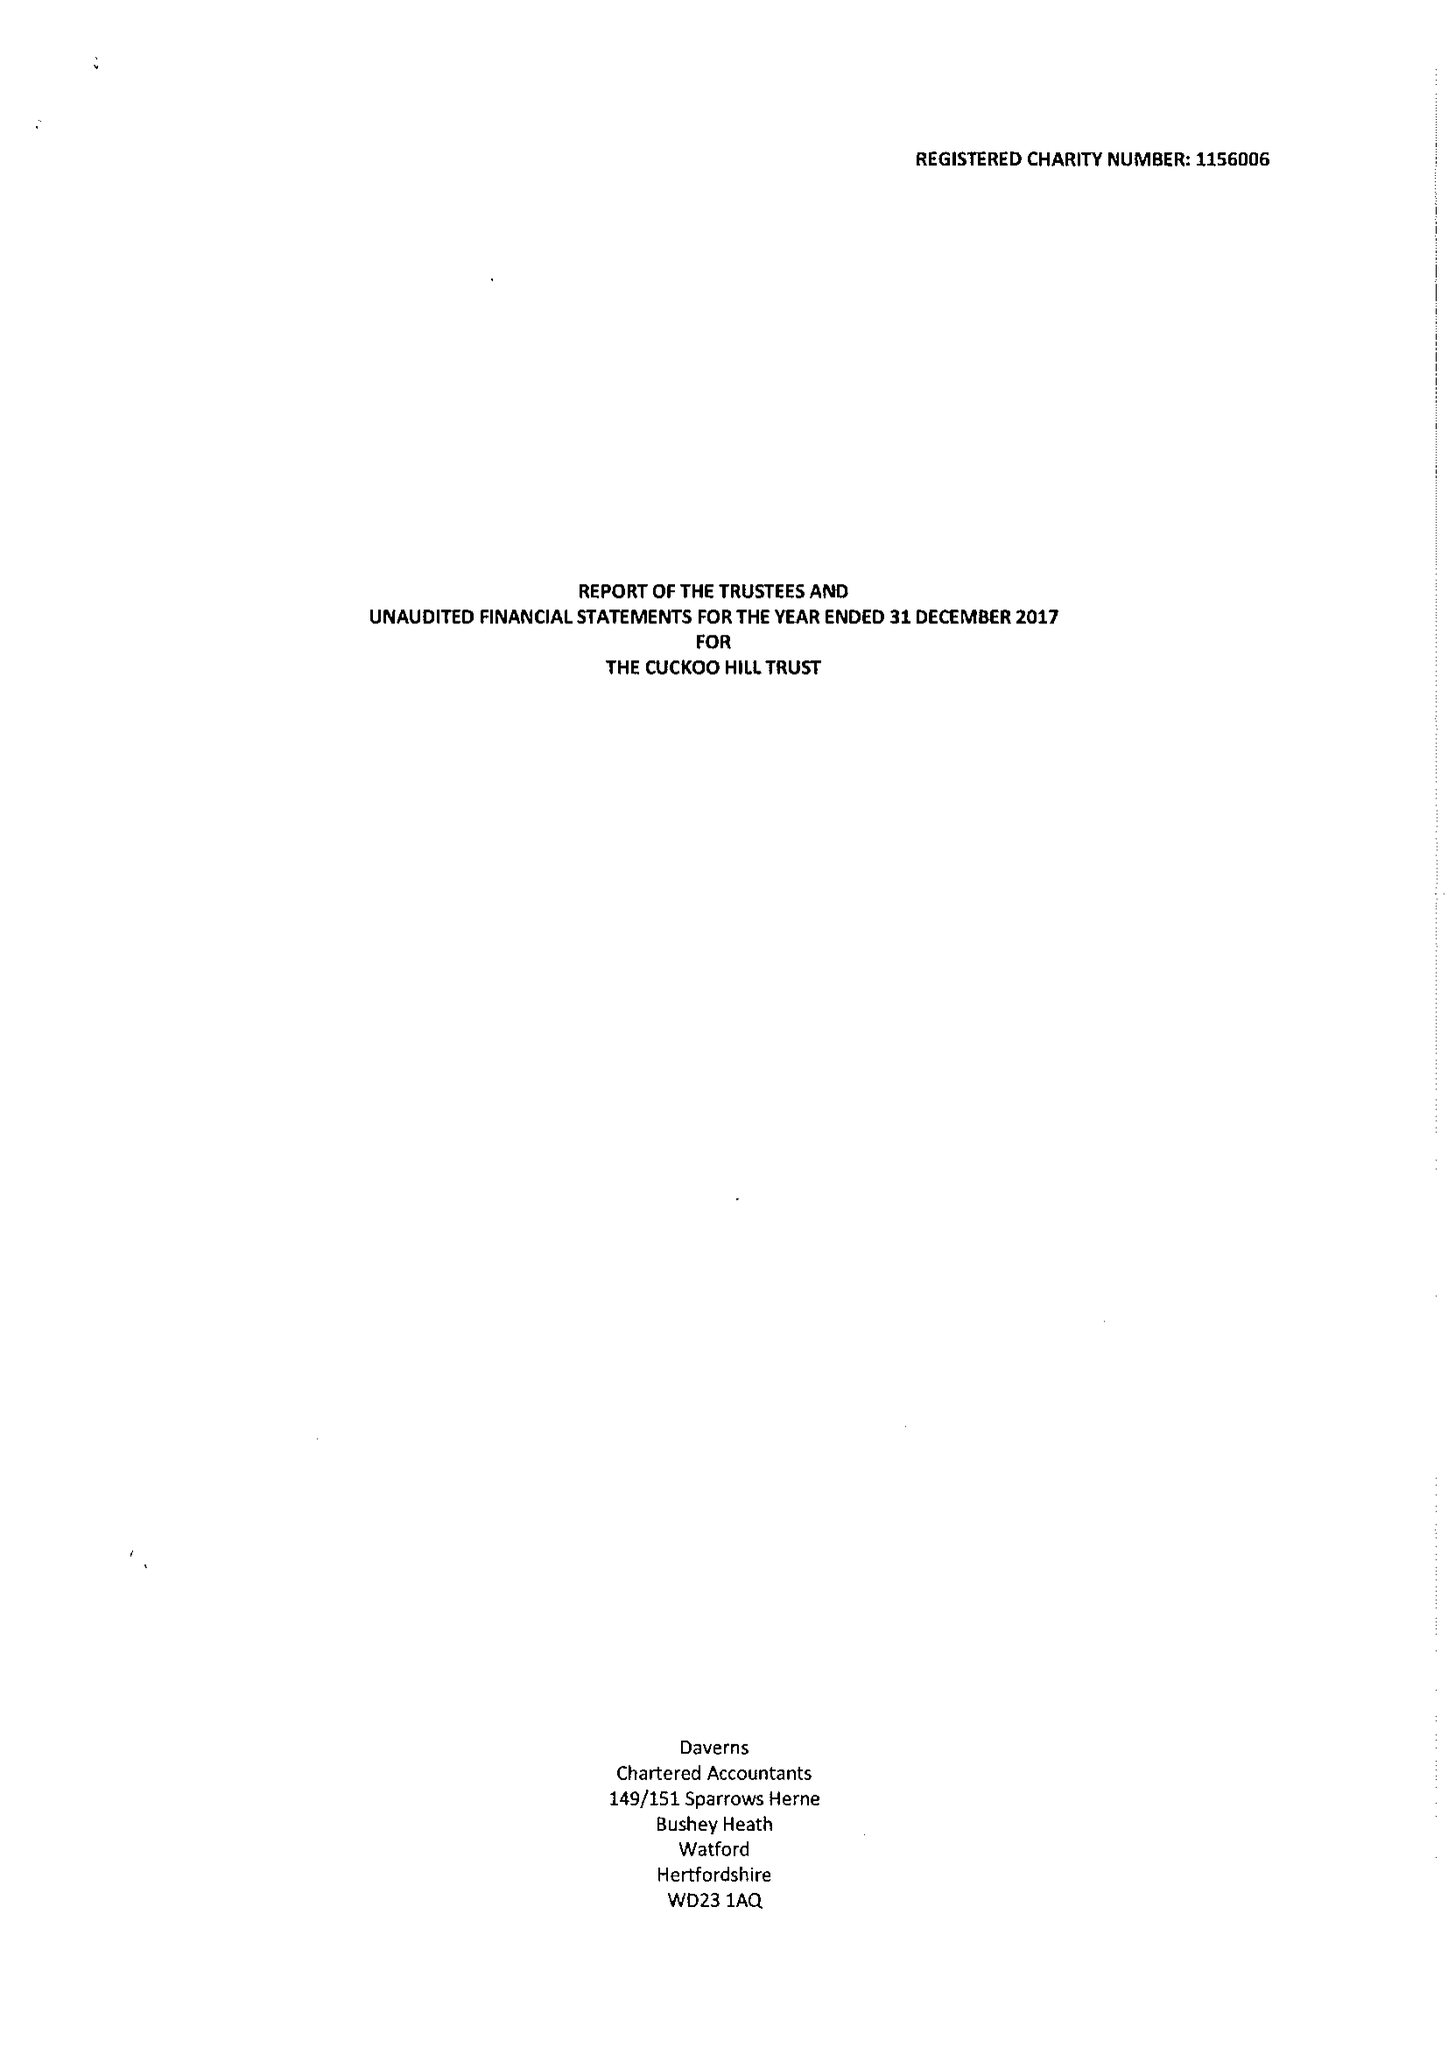What is the value for the spending_annually_in_british_pounds?
Answer the question using a single word or phrase. 89775.00 